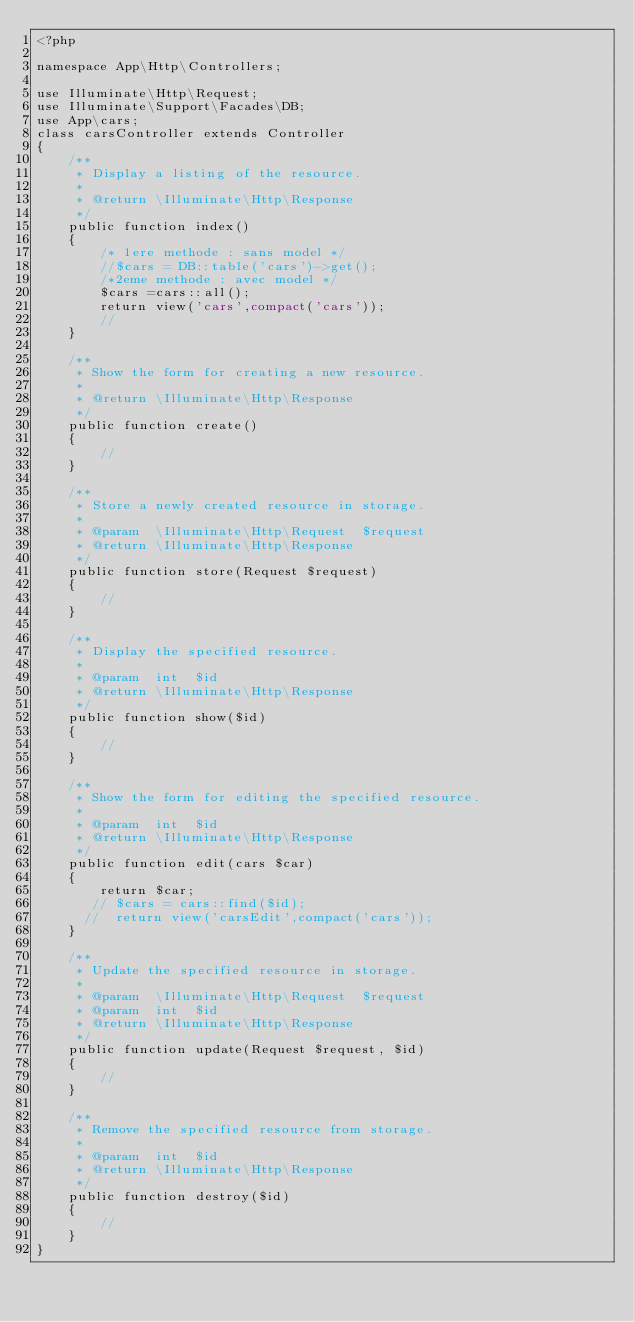<code> <loc_0><loc_0><loc_500><loc_500><_PHP_><?php

namespace App\Http\Controllers;

use Illuminate\Http\Request;
use Illuminate\Support\Facades\DB;
use App\cars;
class carsController extends Controller
{
    /**
     * Display a listing of the resource.
     *
     * @return \Illuminate\Http\Response
     */
    public function index()
    {
        /* 1ere methode : sans model */
        //$cars = DB::table('cars')->get();
        /*2eme methode : avec model */
        $cars =cars::all();
        return view('cars',compact('cars'));
        //
    }

    /**
     * Show the form for creating a new resource.
     *
     * @return \Illuminate\Http\Response
     */
    public function create()
    {
        //
    }

    /**
     * Store a newly created resource in storage.
     *
     * @param  \Illuminate\Http\Request  $request
     * @return \Illuminate\Http\Response
     */
    public function store(Request $request)
    {
        //
    }

    /**
     * Display the specified resource.
     *
     * @param  int  $id
     * @return \Illuminate\Http\Response
     */
    public function show($id)
    {
        //
    }

    /**
     * Show the form for editing the specified resource.
     *
     * @param  int  $id
     * @return \Illuminate\Http\Response
     */
    public function edit(cars $car)
    {
        return $car;
       // $cars = cars::find($id);
      //  return view('carsEdit',compact('cars'));
    }

    /**
     * Update the specified resource in storage.
     *
     * @param  \Illuminate\Http\Request  $request
     * @param  int  $id
     * @return \Illuminate\Http\Response
     */
    public function update(Request $request, $id)
    {
        //
    }

    /**
     * Remove the specified resource from storage.
     *
     * @param  int  $id
     * @return \Illuminate\Http\Response
     */
    public function destroy($id)
    {
        //
    }
}
</code> 